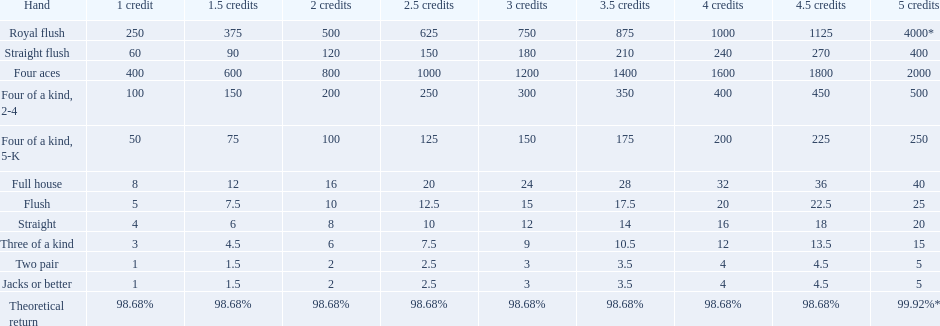What are each of the hands? Royal flush, Straight flush, Four aces, Four of a kind, 2-4, Four of a kind, 5-K, Full house, Flush, Straight, Three of a kind, Two pair, Jacks or better, Theoretical return. Which hand ranks higher between straights and flushes? Flush. 